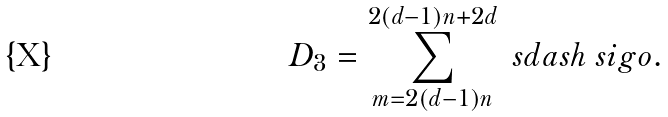<formula> <loc_0><loc_0><loc_500><loc_500>D _ { 3 } = \sum _ { m = 2 ( d - 1 ) n } ^ { 2 ( d - 1 ) n + 2 d } { \ s d a s h \ s i g o } .</formula> 